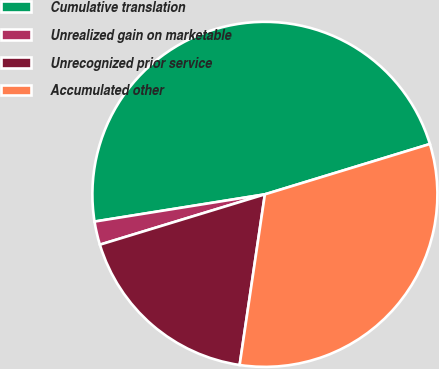Convert chart. <chart><loc_0><loc_0><loc_500><loc_500><pie_chart><fcel>Cumulative translation<fcel>Unrealized gain on marketable<fcel>Unrecognized prior service<fcel>Accumulated other<nl><fcel>47.81%<fcel>2.19%<fcel>17.95%<fcel>32.05%<nl></chart> 